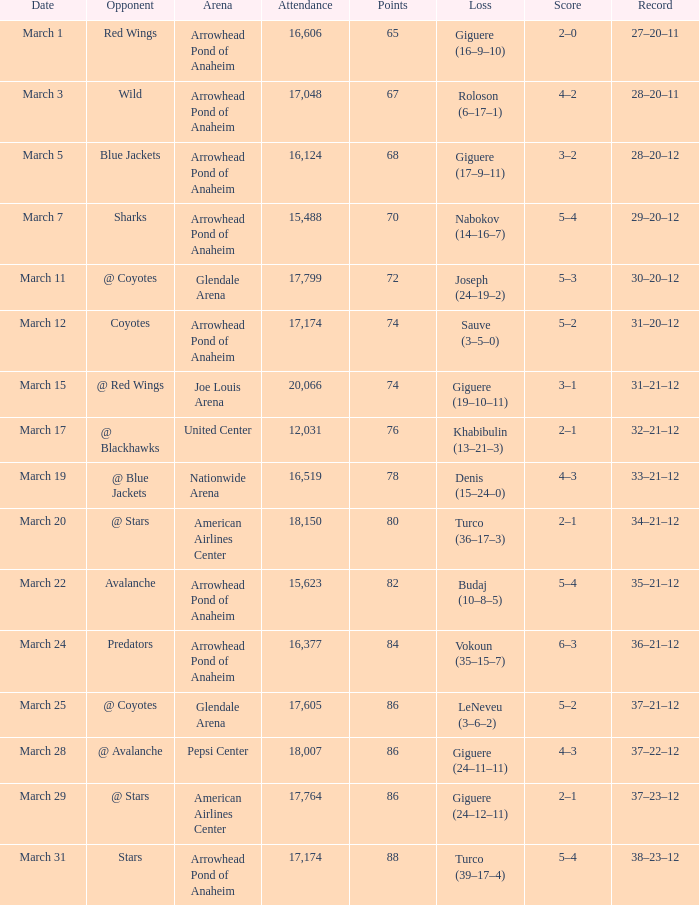Could you help me parse every detail presented in this table? {'header': ['Date', 'Opponent', 'Arena', 'Attendance', 'Points', 'Loss', 'Score', 'Record'], 'rows': [['March 1', 'Red Wings', 'Arrowhead Pond of Anaheim', '16,606', '65', 'Giguere (16–9–10)', '2–0', '27–20–11'], ['March 3', 'Wild', 'Arrowhead Pond of Anaheim', '17,048', '67', 'Roloson (6–17–1)', '4–2', '28–20–11'], ['March 5', 'Blue Jackets', 'Arrowhead Pond of Anaheim', '16,124', '68', 'Giguere (17–9–11)', '3–2', '28–20–12'], ['March 7', 'Sharks', 'Arrowhead Pond of Anaheim', '15,488', '70', 'Nabokov (14–16–7)', '5–4', '29–20–12'], ['March 11', '@ Coyotes', 'Glendale Arena', '17,799', '72', 'Joseph (24–19–2)', '5–3', '30–20–12'], ['March 12', 'Coyotes', 'Arrowhead Pond of Anaheim', '17,174', '74', 'Sauve (3–5–0)', '5–2', '31–20–12'], ['March 15', '@ Red Wings', 'Joe Louis Arena', '20,066', '74', 'Giguere (19–10–11)', '3–1', '31–21–12'], ['March 17', '@ Blackhawks', 'United Center', '12,031', '76', 'Khabibulin (13–21–3)', '2–1', '32–21–12'], ['March 19', '@ Blue Jackets', 'Nationwide Arena', '16,519', '78', 'Denis (15–24–0)', '4–3', '33–21–12'], ['March 20', '@ Stars', 'American Airlines Center', '18,150', '80', 'Turco (36–17–3)', '2–1', '34–21–12'], ['March 22', 'Avalanche', 'Arrowhead Pond of Anaheim', '15,623', '82', 'Budaj (10–8–5)', '5–4', '35–21–12'], ['March 24', 'Predators', 'Arrowhead Pond of Anaheim', '16,377', '84', 'Vokoun (35–15–7)', '6–3', '36–21–12'], ['March 25', '@ Coyotes', 'Glendale Arena', '17,605', '86', 'LeNeveu (3–6–2)', '5–2', '37–21–12'], ['March 28', '@ Avalanche', 'Pepsi Center', '18,007', '86', 'Giguere (24–11–11)', '4–3', '37–22–12'], ['March 29', '@ Stars', 'American Airlines Center', '17,764', '86', 'Giguere (24–12–11)', '2–1', '37–23–12'], ['March 31', 'Stars', 'Arrowhead Pond of Anaheim', '17,174', '88', 'Turco (39–17–4)', '5–4', '38–23–12']]} What is the Attendance at Joe Louis Arena? 20066.0. 